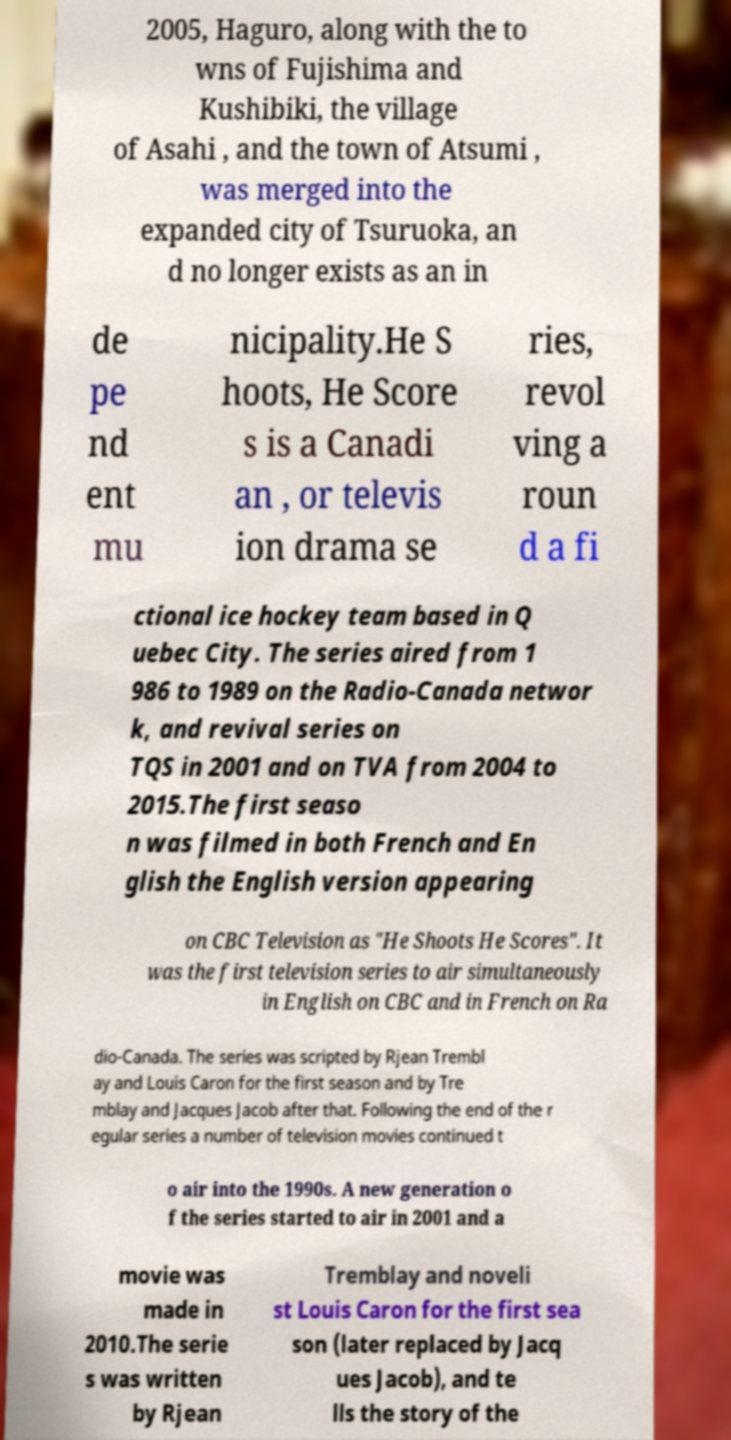What messages or text are displayed in this image? I need them in a readable, typed format. 2005, Haguro, along with the to wns of Fujishima and Kushibiki, the village of Asahi , and the town of Atsumi , was merged into the expanded city of Tsuruoka, an d no longer exists as an in de pe nd ent mu nicipality.He S hoots, He Score s is a Canadi an , or televis ion drama se ries, revol ving a roun d a fi ctional ice hockey team based in Q uebec City. The series aired from 1 986 to 1989 on the Radio-Canada networ k, and revival series on TQS in 2001 and on TVA from 2004 to 2015.The first seaso n was filmed in both French and En glish the English version appearing on CBC Television as "He Shoots He Scores". It was the first television series to air simultaneously in English on CBC and in French on Ra dio-Canada. The series was scripted by Rjean Trembl ay and Louis Caron for the first season and by Tre mblay and Jacques Jacob after that. Following the end of the r egular series a number of television movies continued t o air into the 1990s. A new generation o f the series started to air in 2001 and a movie was made in 2010.The serie s was written by Rjean Tremblay and noveli st Louis Caron for the first sea son (later replaced by Jacq ues Jacob), and te lls the story of the 